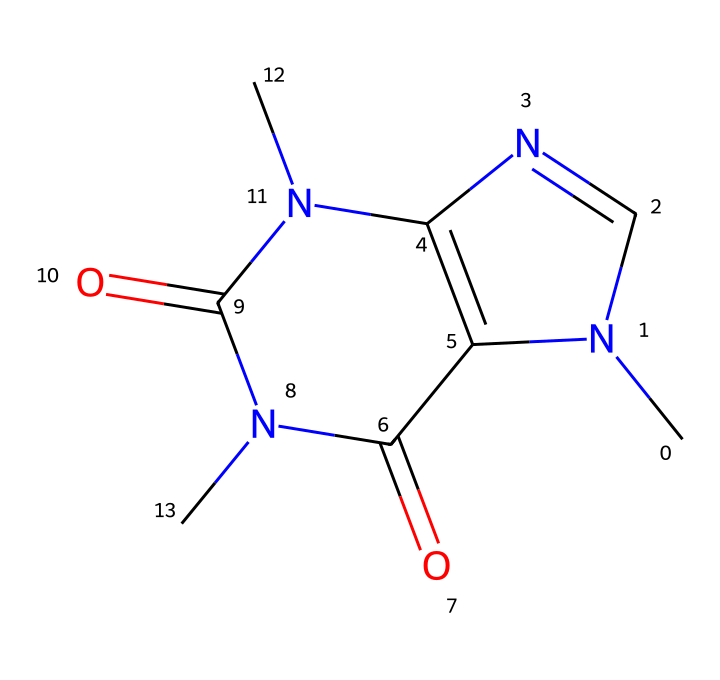What is the name of this chemical? The SMILES representation refers to a compound with the molecular structure identified as caffeine. This is a well-documented chemical commonly found in coffee.
Answer: caffeine How many nitrogen atoms are in the structure? By analyzing the SMILES notation, we can identify three 'N' symbols, indicating the presence of three nitrogen atoms in the structure of caffeine.
Answer: three What type of chemical structure does caffeine have? Caffeine is classified as a xanthine alkaloid due to its complex structure that includes a fused ring system and nitrogen atoms characteristic of alkaloids.
Answer: xanthine alkaloid What is the molecular formula for caffeine? From the structure represented in the SMILES, we can deduce the molecular formula C8H10N4O2, reflecting the elements and their quantities present in caffeine.
Answer: C8H10N4O2 Which part of caffeine contributes to its stimulant effect? The nitrogen atoms in the structure, particularly in the rings, play a significant role in interacting with adenosine receptors in the brain, leading to its stimulant properties.
Answer: nitrogen atoms What is the overall charge of the caffeine molecule? The structure indicates that caffeine has no overall charge; it is a neutral molecule as there are an equal number of protons and electrons in its structure.
Answer: neutral How many rings are present in the caffeine molecule? Upon examining the structure, we can see that there are two fused rings within the molecular structure of caffeine, characteristic of purine derivatives.
Answer: two 